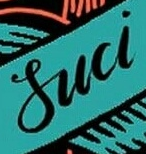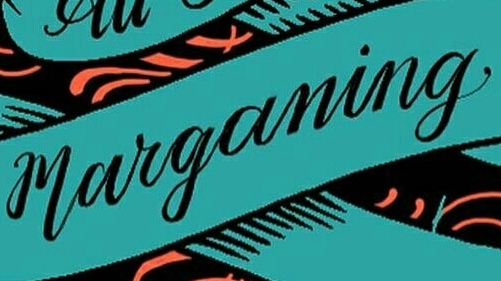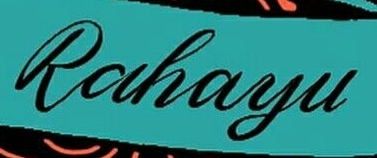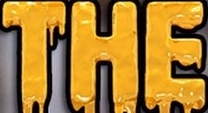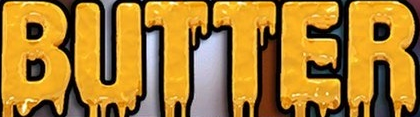What words are shown in these images in order, separated by a semicolon? Suci; marganing; Rahayu; THE; BUTTER 